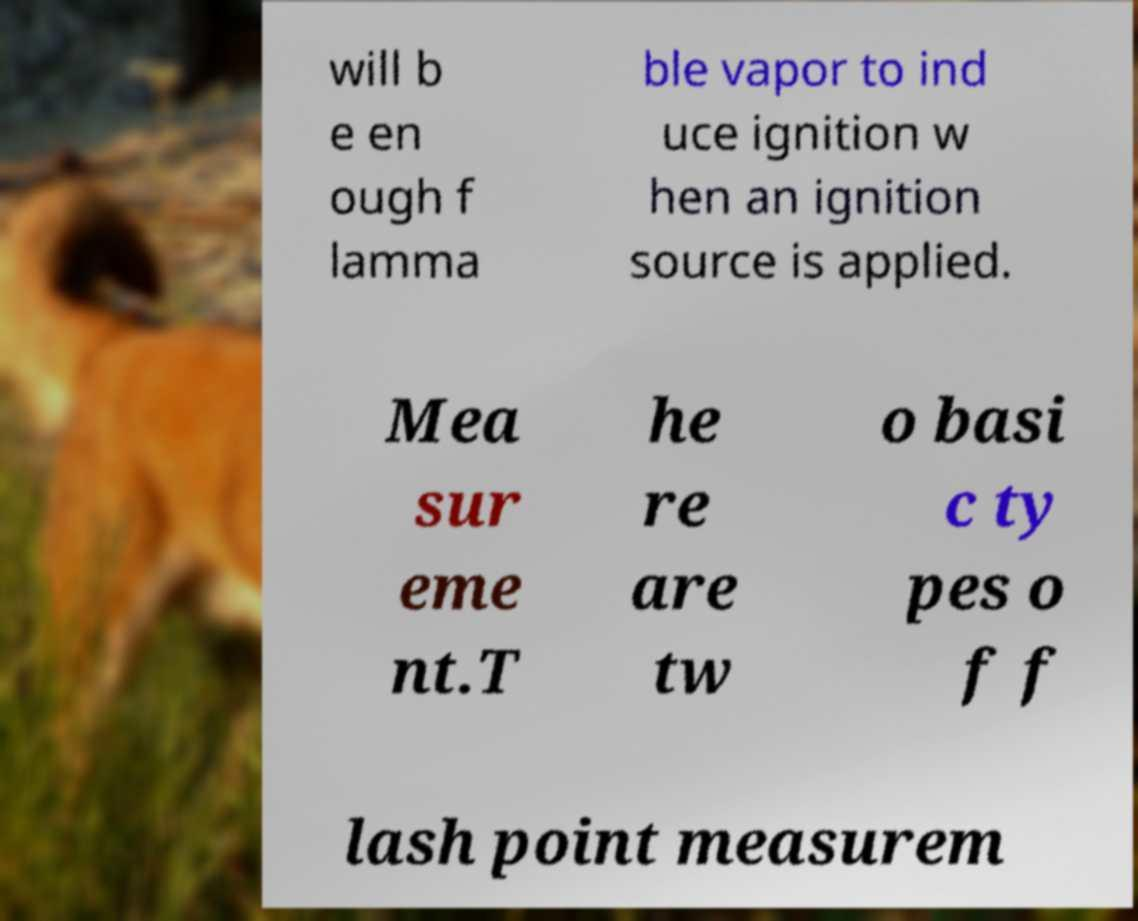Can you read and provide the text displayed in the image?This photo seems to have some interesting text. Can you extract and type it out for me? will b e en ough f lamma ble vapor to ind uce ignition w hen an ignition source is applied. Mea sur eme nt.T he re are tw o basi c ty pes o f f lash point measurem 